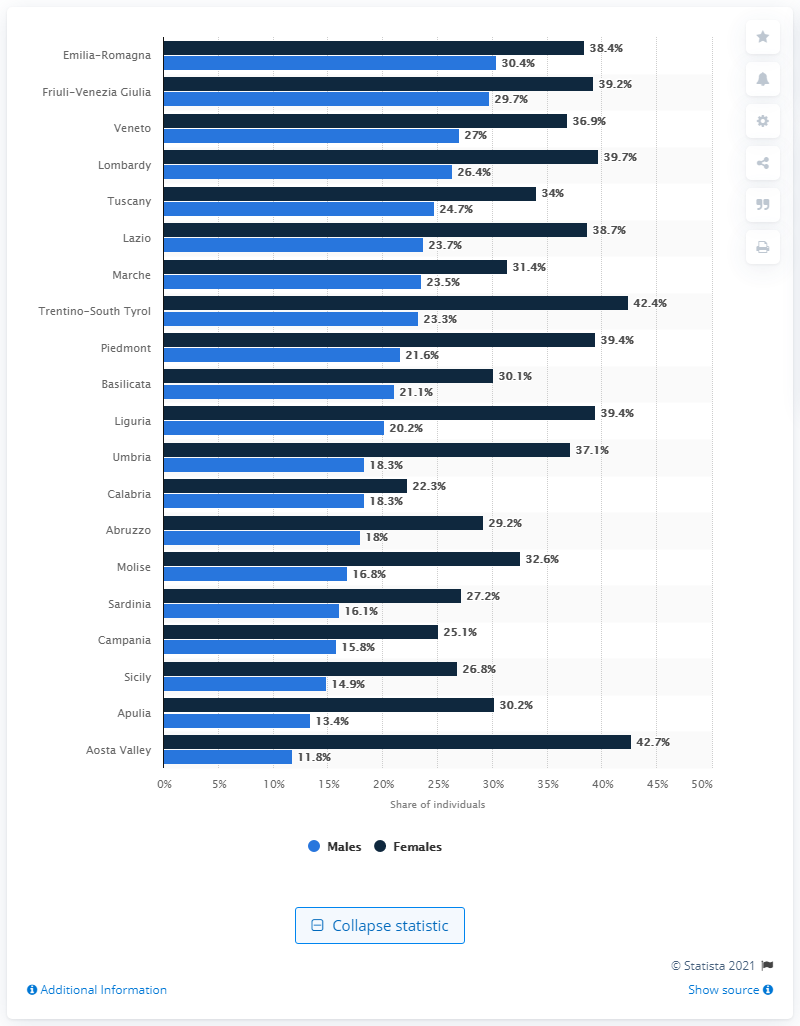Indicate a few pertinent items in this graphic. The region of Emilia-Romagna had the highest percentage of graduated men among all regions in Italy. In the Aosta Valley, the highest percentage of women with tertiary education is registered. 